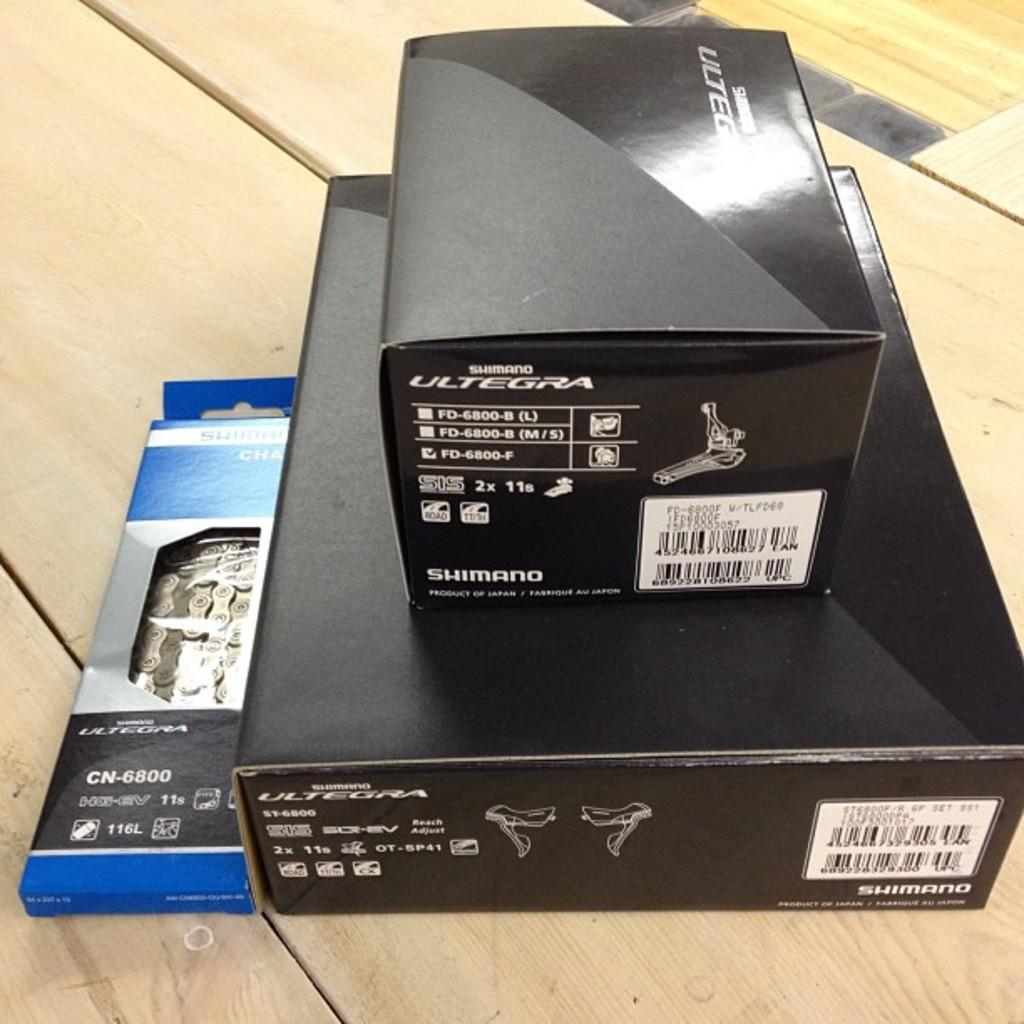<image>
Offer a succinct explanation of the picture presented. Some boxes, one of which has the word Shimano on it 